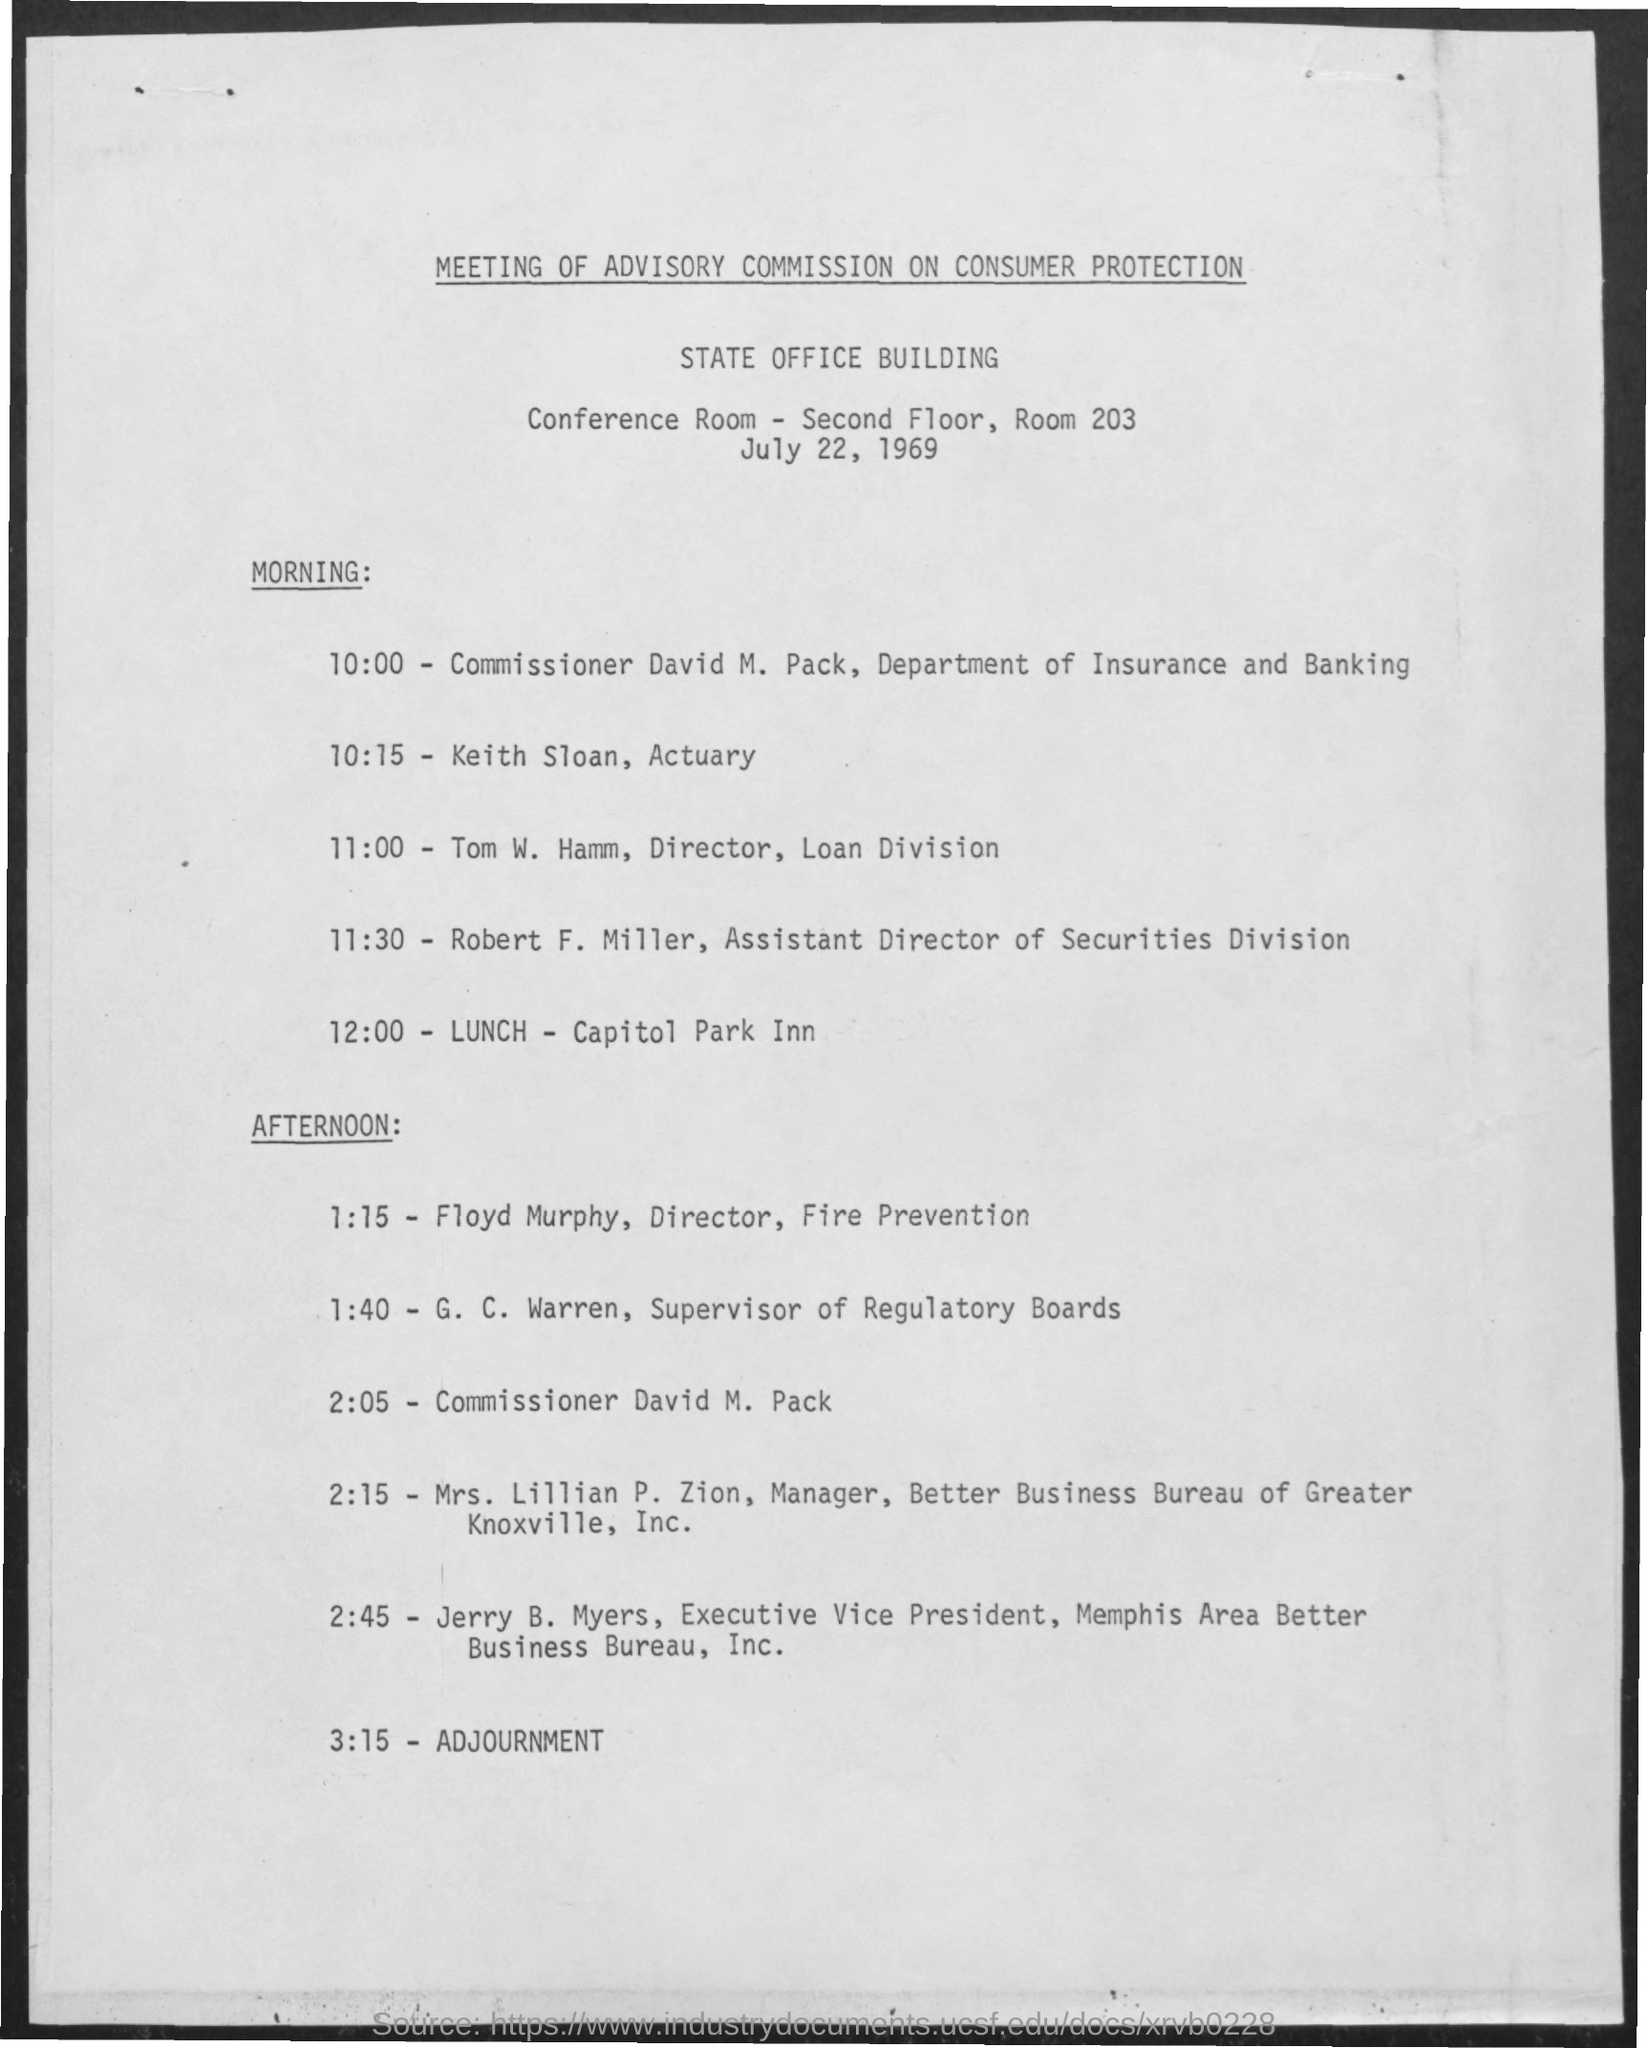What does the afternoon schedule imply about the professionals attending? The afternoon schedule of the Advisory Commission on Consumer Protection indicates that professionals from diverse fields related to consumer protection, such as fire prevention, regulatory boards, and business bureaus, were in attendance. This diversity points to a comprehensive approach to discussing and addressing consumer protection issues. 